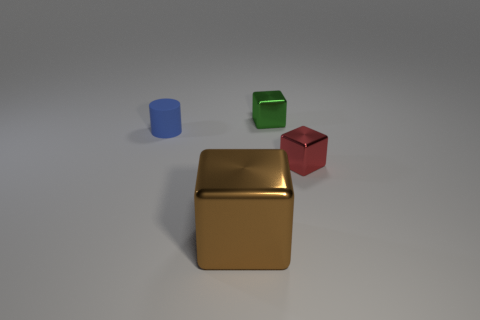Subtract all tiny green shiny blocks. How many blocks are left? 2 Add 4 big green matte objects. How many objects exist? 8 Subtract all cylinders. How many objects are left? 3 Add 4 small metallic things. How many small metallic things are left? 6 Add 4 blue spheres. How many blue spheres exist? 4 Subtract 0 purple blocks. How many objects are left? 4 Subtract all large brown matte cubes. Subtract all green shiny objects. How many objects are left? 3 